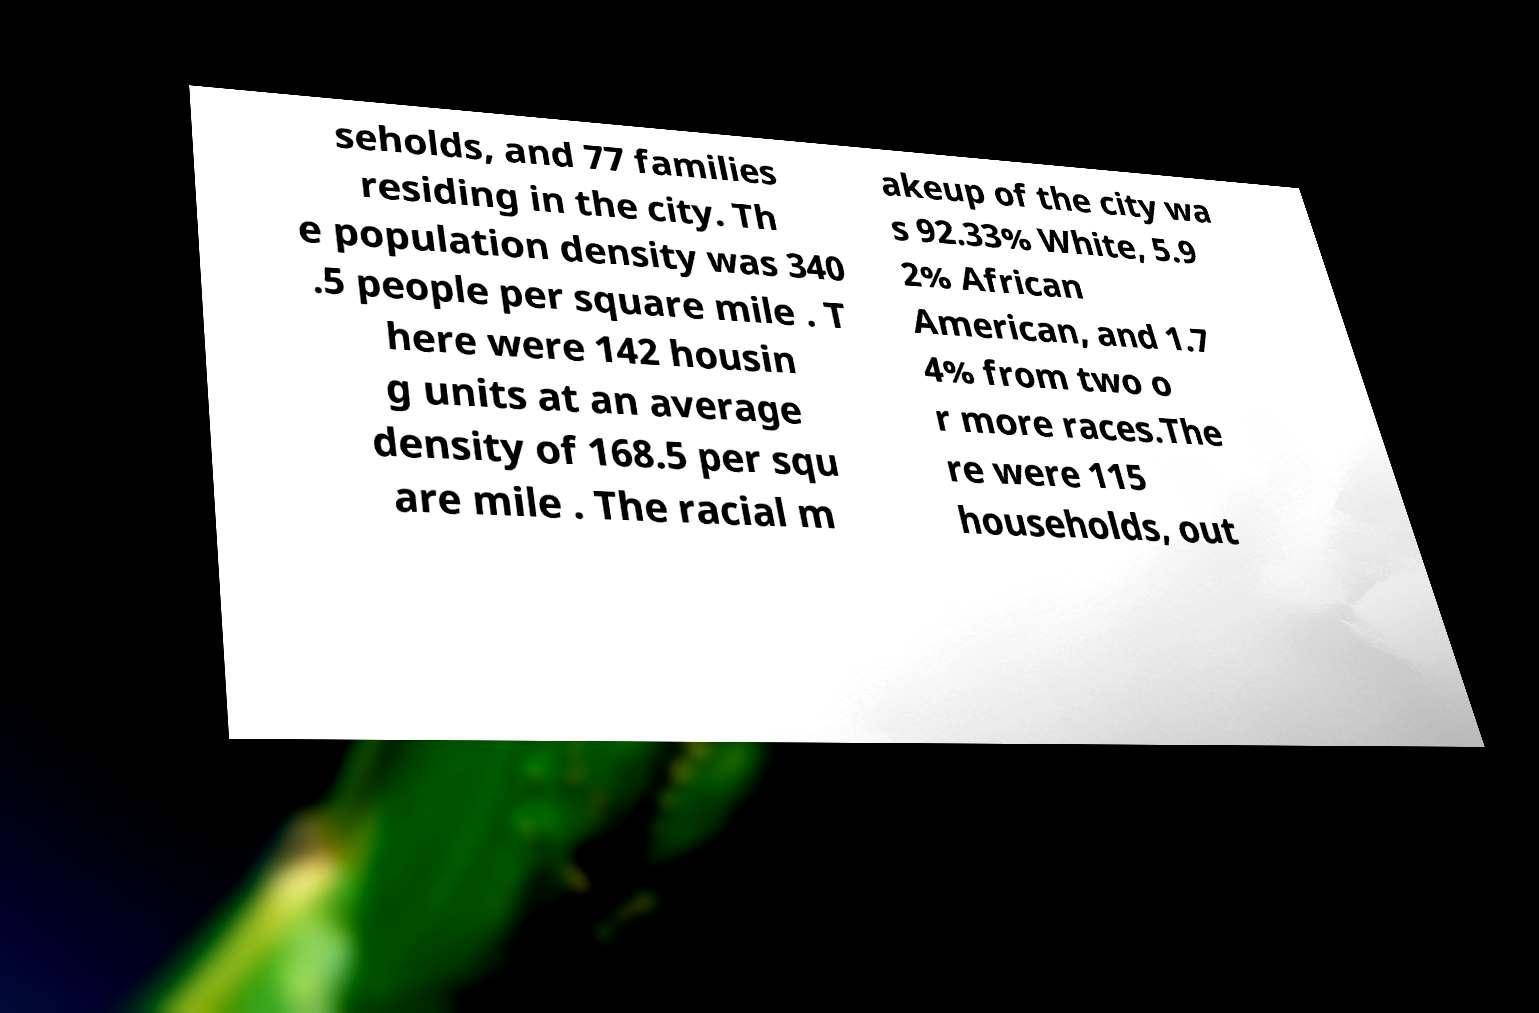There's text embedded in this image that I need extracted. Can you transcribe it verbatim? seholds, and 77 families residing in the city. Th e population density was 340 .5 people per square mile . T here were 142 housin g units at an average density of 168.5 per squ are mile . The racial m akeup of the city wa s 92.33% White, 5.9 2% African American, and 1.7 4% from two o r more races.The re were 115 households, out 